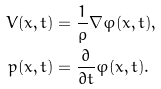Convert formula to latex. <formula><loc_0><loc_0><loc_500><loc_500>V ( x , t ) & = \frac { 1 } { \rho } \nabla \varphi ( x , t ) , \\ p ( x , t ) & = \frac { \partial } { \partial t } \varphi ( x , t ) .</formula> 